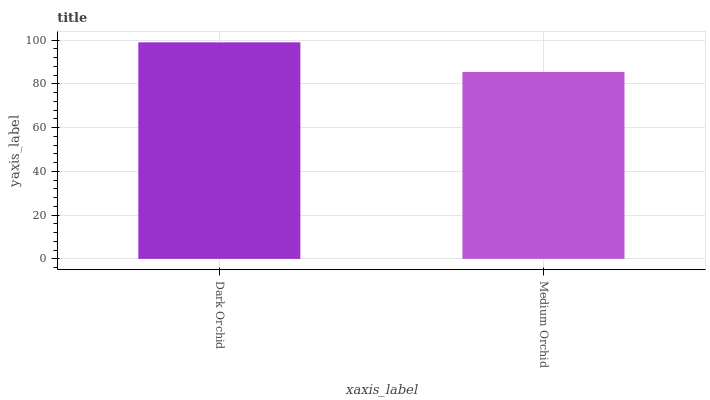Is Medium Orchid the minimum?
Answer yes or no. Yes. Is Dark Orchid the maximum?
Answer yes or no. Yes. Is Medium Orchid the maximum?
Answer yes or no. No. Is Dark Orchid greater than Medium Orchid?
Answer yes or no. Yes. Is Medium Orchid less than Dark Orchid?
Answer yes or no. Yes. Is Medium Orchid greater than Dark Orchid?
Answer yes or no. No. Is Dark Orchid less than Medium Orchid?
Answer yes or no. No. Is Dark Orchid the high median?
Answer yes or no. Yes. Is Medium Orchid the low median?
Answer yes or no. Yes. Is Medium Orchid the high median?
Answer yes or no. No. Is Dark Orchid the low median?
Answer yes or no. No. 